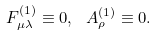<formula> <loc_0><loc_0><loc_500><loc_500>F _ { \mu \lambda } ^ { ( 1 ) } \equiv 0 , \ A _ { \rho } ^ { ( 1 ) } \equiv 0 .</formula> 